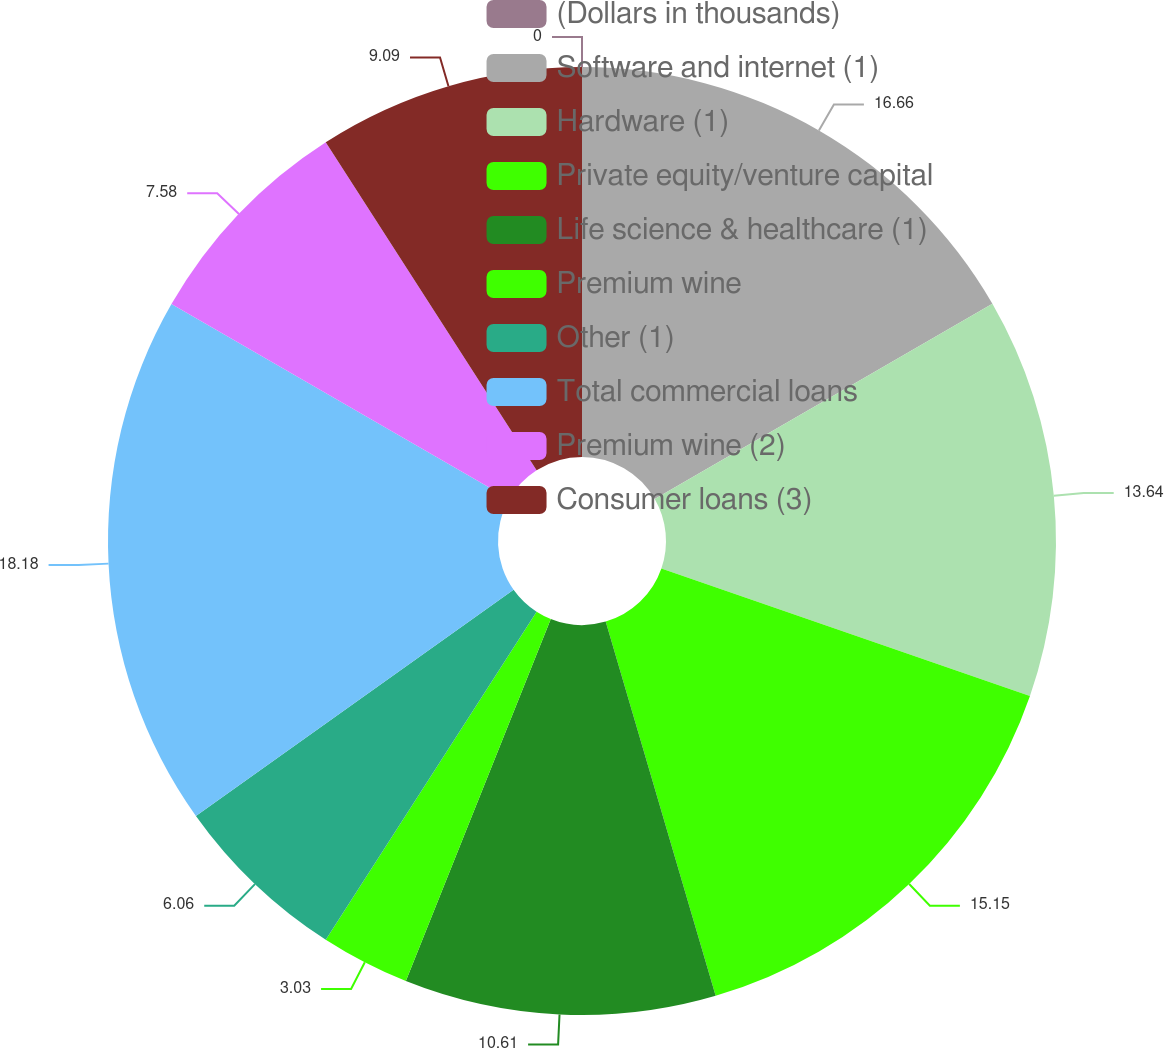Convert chart to OTSL. <chart><loc_0><loc_0><loc_500><loc_500><pie_chart><fcel>(Dollars in thousands)<fcel>Software and internet (1)<fcel>Hardware (1)<fcel>Private equity/venture capital<fcel>Life science & healthcare (1)<fcel>Premium wine<fcel>Other (1)<fcel>Total commercial loans<fcel>Premium wine (2)<fcel>Consumer loans (3)<nl><fcel>0.0%<fcel>16.66%<fcel>13.64%<fcel>15.15%<fcel>10.61%<fcel>3.03%<fcel>6.06%<fcel>18.18%<fcel>7.58%<fcel>9.09%<nl></chart> 